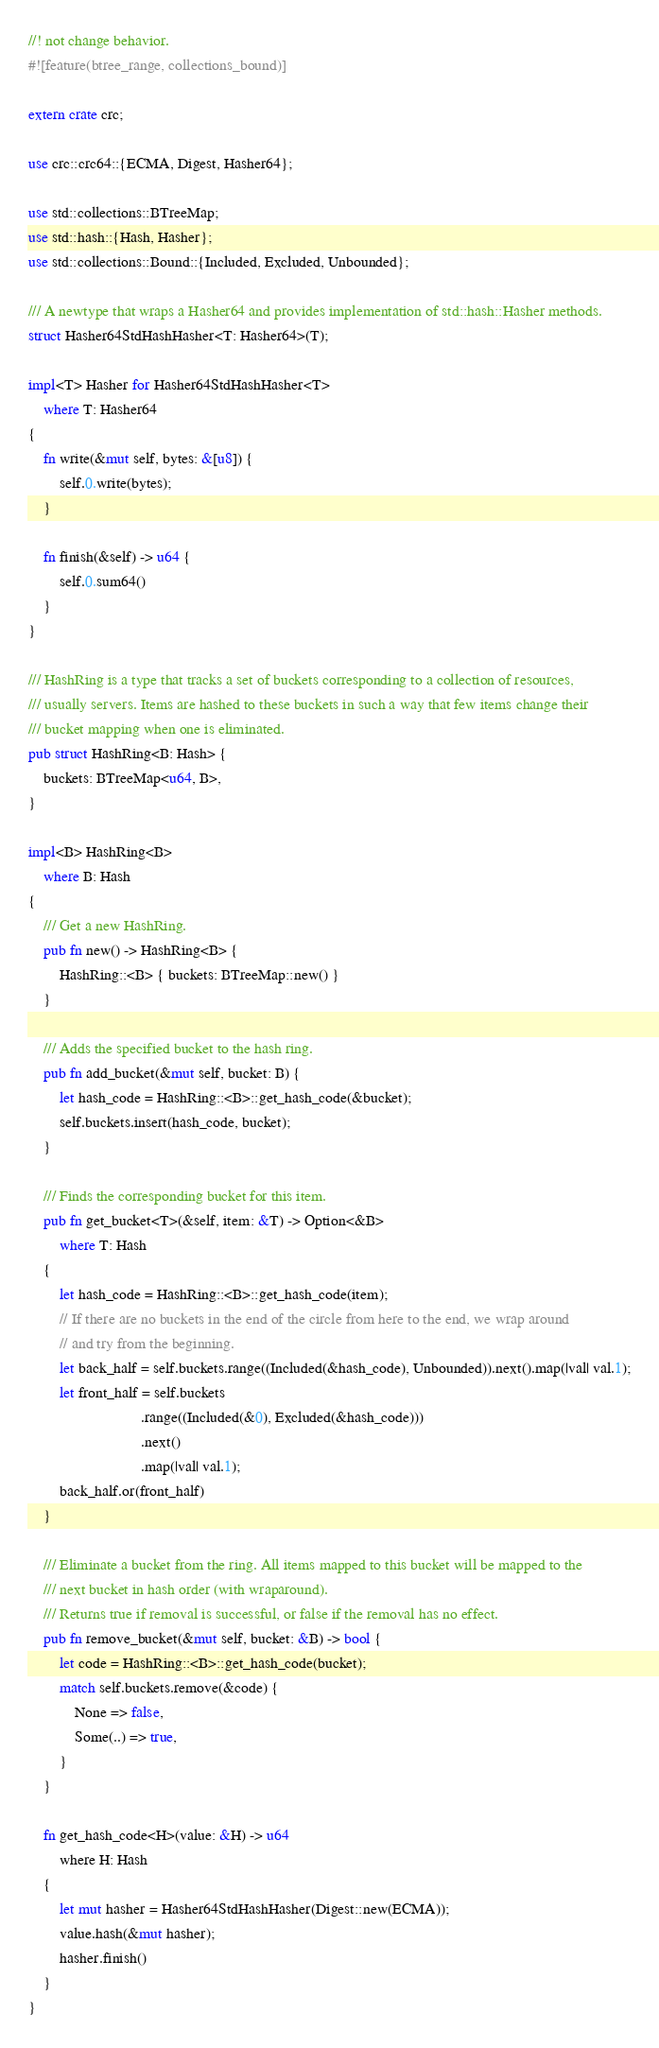Convert code to text. <code><loc_0><loc_0><loc_500><loc_500><_Rust_>//! not change behavior.
#![feature(btree_range, collections_bound)]

extern crate crc;

use crc::crc64::{ECMA, Digest, Hasher64};

use std::collections::BTreeMap;
use std::hash::{Hash, Hasher};
use std::collections::Bound::{Included, Excluded, Unbounded};

/// A newtype that wraps a Hasher64 and provides implementation of std::hash::Hasher methods.
struct Hasher64StdHashHasher<T: Hasher64>(T);

impl<T> Hasher for Hasher64StdHashHasher<T>
    where T: Hasher64
{
    fn write(&mut self, bytes: &[u8]) {
        self.0.write(bytes);
    }

    fn finish(&self) -> u64 {
        self.0.sum64()
    }
}

/// HashRing is a type that tracks a set of buckets corresponding to a collection of resources,
/// usually servers. Items are hashed to these buckets in such a way that few items change their
/// bucket mapping when one is eliminated.
pub struct HashRing<B: Hash> {
    buckets: BTreeMap<u64, B>,
}

impl<B> HashRing<B>
    where B: Hash
{
    /// Get a new HashRing.
    pub fn new() -> HashRing<B> {
        HashRing::<B> { buckets: BTreeMap::new() }
    }

    /// Adds the specified bucket to the hash ring.
    pub fn add_bucket(&mut self, bucket: B) {
        let hash_code = HashRing::<B>::get_hash_code(&bucket);
        self.buckets.insert(hash_code, bucket);
    }

    /// Finds the corresponding bucket for this item.
    pub fn get_bucket<T>(&self, item: &T) -> Option<&B>
        where T: Hash
    {
        let hash_code = HashRing::<B>::get_hash_code(item);
        // If there are no buckets in the end of the circle from here to the end, we wrap around
        // and try from the beginning.
        let back_half = self.buckets.range((Included(&hash_code), Unbounded)).next().map(|val| val.1);
        let front_half = self.buckets
                             .range((Included(&0), Excluded(&hash_code)))
                             .next()
                             .map(|val| val.1);
        back_half.or(front_half)
    }

    /// Eliminate a bucket from the ring. All items mapped to this bucket will be mapped to the
    /// next bucket in hash order (with wraparound).
    /// Returns true if removal is successful, or false if the removal has no effect.
    pub fn remove_bucket(&mut self, bucket: &B) -> bool {
        let code = HashRing::<B>::get_hash_code(bucket);
        match self.buckets.remove(&code) {
            None => false,
            Some(..) => true,
        }
    }

    fn get_hash_code<H>(value: &H) -> u64
        where H: Hash
    {
        let mut hasher = Hasher64StdHashHasher(Digest::new(ECMA));
        value.hash(&mut hasher);
        hasher.finish()
    }
}
</code> 